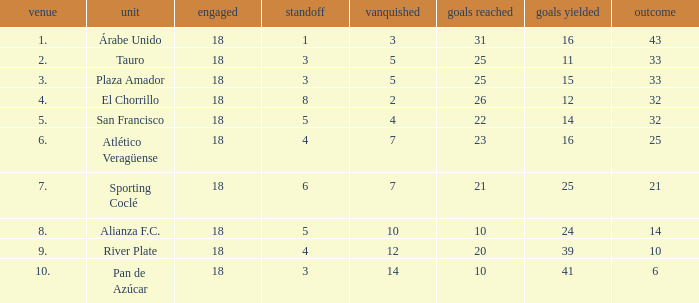How many points did the team have that conceded 41 goals and finish in a place larger than 10? 0.0. 